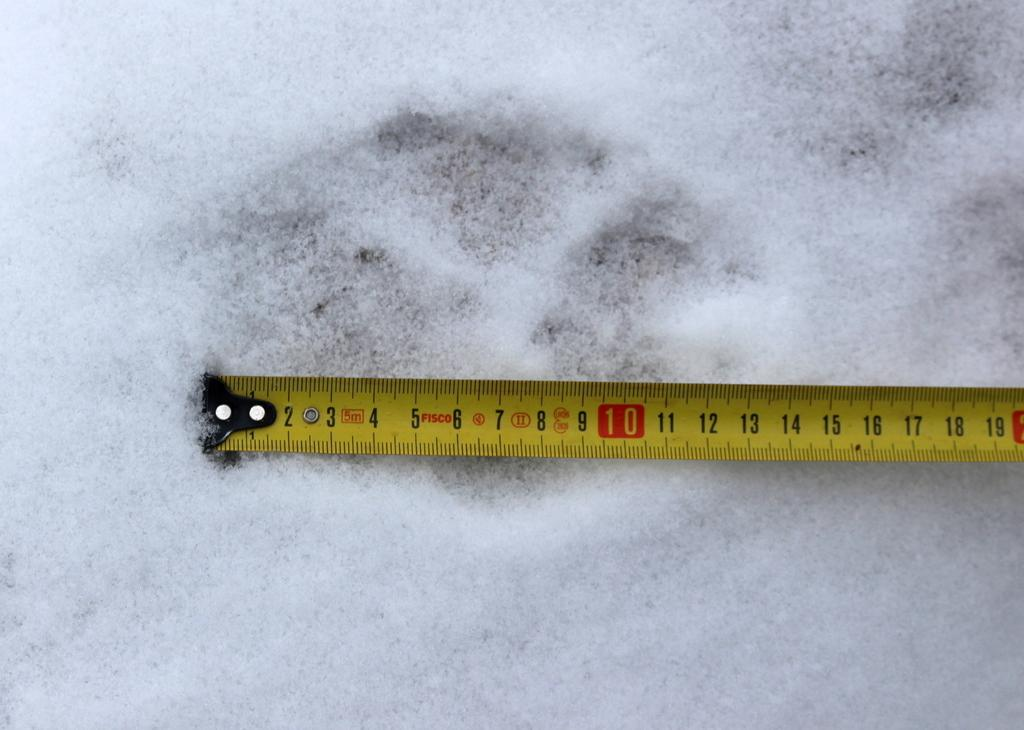<image>
Present a compact description of the photo's key features. The number 10 on this measuring tape is highlighted in red. 